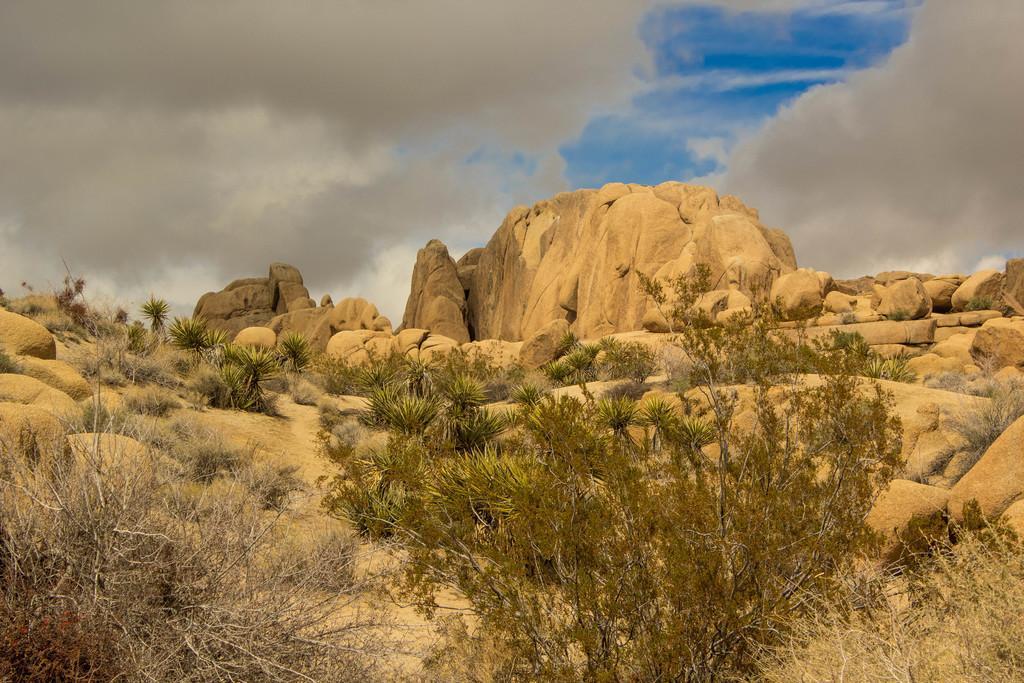Could you give a brief overview of what you see in this image? In the picture I can see a plant which is in green color and there are dried trees on either sides of it and there are few rocks and plants in front of it and the sky is cloudy. 